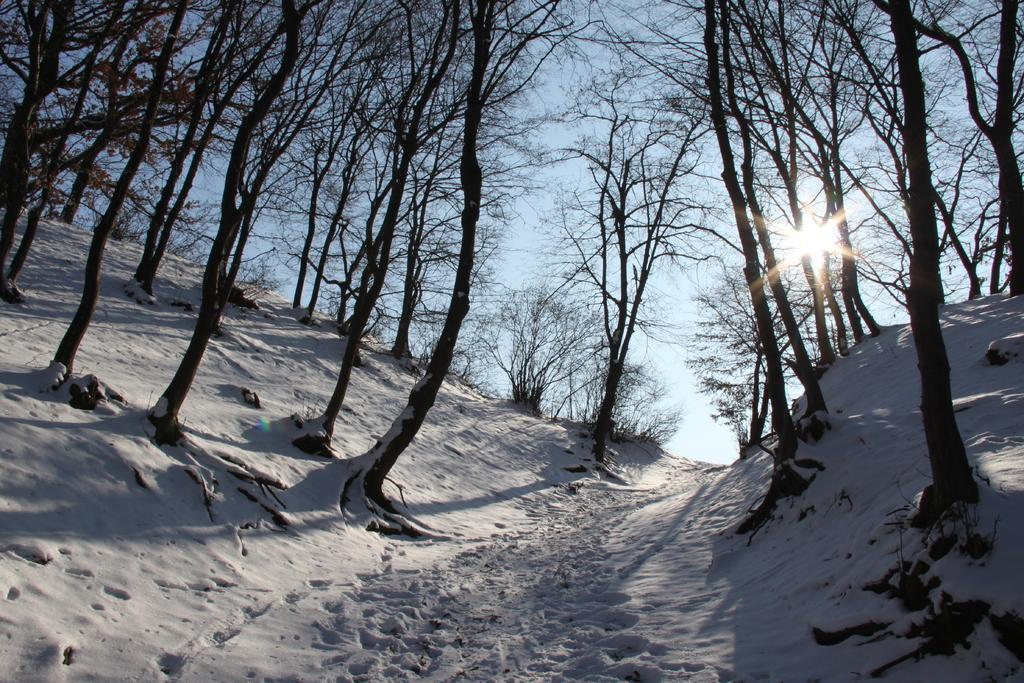What is the color of the snow in the image? The snow in the image is white. What can be seen in the background of the image? There are dried trees in the background of the image. What is the color of the sky in the image? The sky is blue in the image. Is the father reading a book in the image? There is no father or book present in the image. 